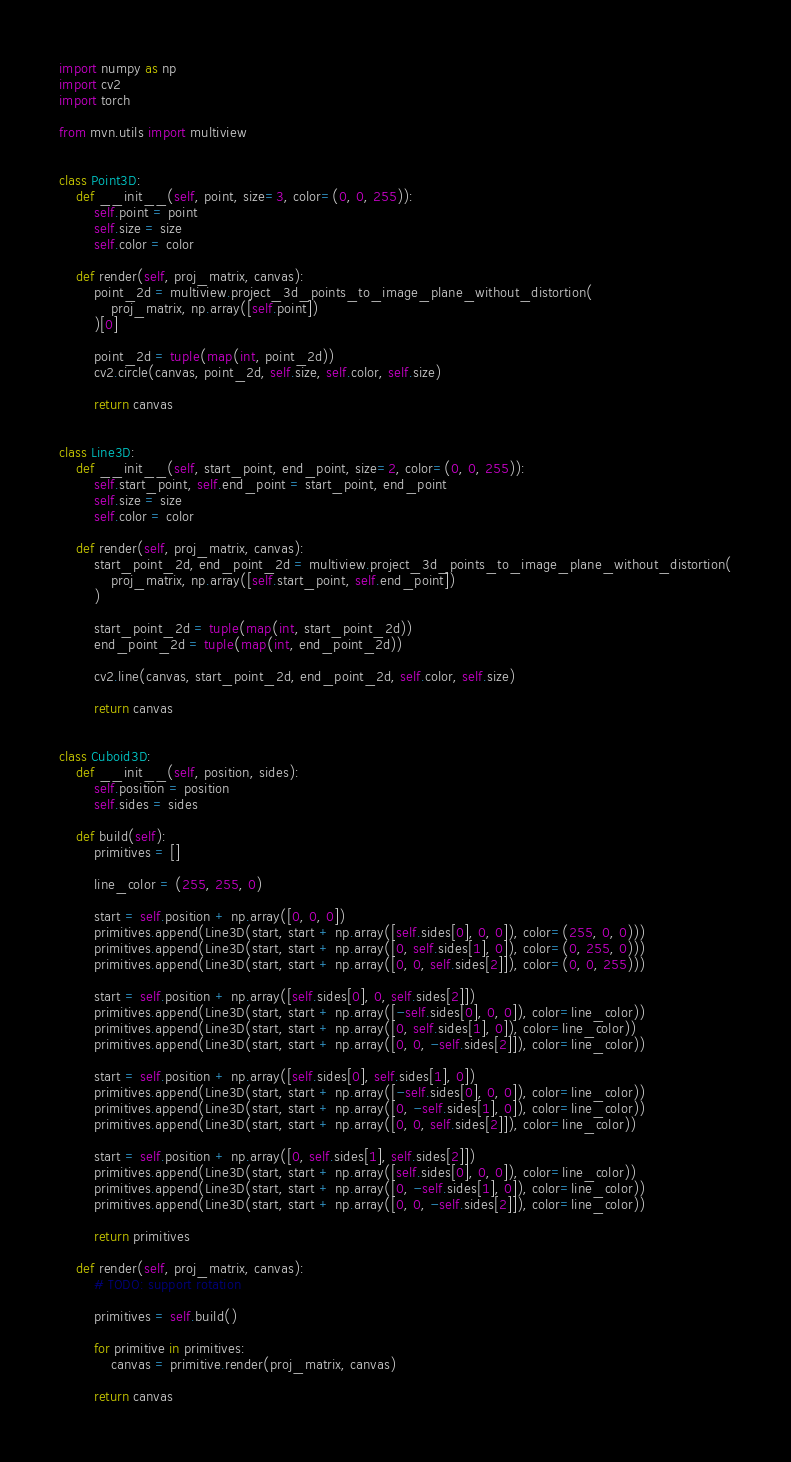Convert code to text. <code><loc_0><loc_0><loc_500><loc_500><_Python_>import numpy as np
import cv2
import torch

from mvn.utils import multiview


class Point3D:
    def __init__(self, point, size=3, color=(0, 0, 255)):
        self.point = point
        self.size = size
        self.color = color

    def render(self, proj_matrix, canvas):
        point_2d = multiview.project_3d_points_to_image_plane_without_distortion(
            proj_matrix, np.array([self.point])
        )[0]

        point_2d = tuple(map(int, point_2d))
        cv2.circle(canvas, point_2d, self.size, self.color, self.size)

        return canvas


class Line3D:
    def __init__(self, start_point, end_point, size=2, color=(0, 0, 255)):
        self.start_point, self.end_point = start_point, end_point
        self.size = size
        self.color = color

    def render(self, proj_matrix, canvas):
        start_point_2d, end_point_2d = multiview.project_3d_points_to_image_plane_without_distortion(
            proj_matrix, np.array([self.start_point, self.end_point])
        )

        start_point_2d = tuple(map(int, start_point_2d))
        end_point_2d = tuple(map(int, end_point_2d))

        cv2.line(canvas, start_point_2d, end_point_2d, self.color, self.size)

        return canvas


class Cuboid3D:
    def __init__(self, position, sides):
        self.position = position
        self.sides = sides

    def build(self):
        primitives = []

        line_color = (255, 255, 0)

        start = self.position + np.array([0, 0, 0])
        primitives.append(Line3D(start, start + np.array([self.sides[0], 0, 0]), color=(255, 0, 0)))
        primitives.append(Line3D(start, start + np.array([0, self.sides[1], 0]), color=(0, 255, 0)))
        primitives.append(Line3D(start, start + np.array([0, 0, self.sides[2]]), color=(0, 0, 255)))

        start = self.position + np.array([self.sides[0], 0, self.sides[2]])
        primitives.append(Line3D(start, start + np.array([-self.sides[0], 0, 0]), color=line_color))
        primitives.append(Line3D(start, start + np.array([0, self.sides[1], 0]), color=line_color))
        primitives.append(Line3D(start, start + np.array([0, 0, -self.sides[2]]), color=line_color))

        start = self.position + np.array([self.sides[0], self.sides[1], 0])
        primitives.append(Line3D(start, start + np.array([-self.sides[0], 0, 0]), color=line_color))
        primitives.append(Line3D(start, start + np.array([0, -self.sides[1], 0]), color=line_color))
        primitives.append(Line3D(start, start + np.array([0, 0, self.sides[2]]), color=line_color))

        start = self.position + np.array([0, self.sides[1], self.sides[2]])
        primitives.append(Line3D(start, start + np.array([self.sides[0], 0, 0]), color=line_color))
        primitives.append(Line3D(start, start + np.array([0, -self.sides[1], 0]), color=line_color))
        primitives.append(Line3D(start, start + np.array([0, 0, -self.sides[2]]), color=line_color))

        return primitives

    def render(self, proj_matrix, canvas):
        # TODO: support rotation

        primitives = self.build()

        for primitive in primitives:
            canvas = primitive.render(proj_matrix, canvas)

        return canvas

</code> 